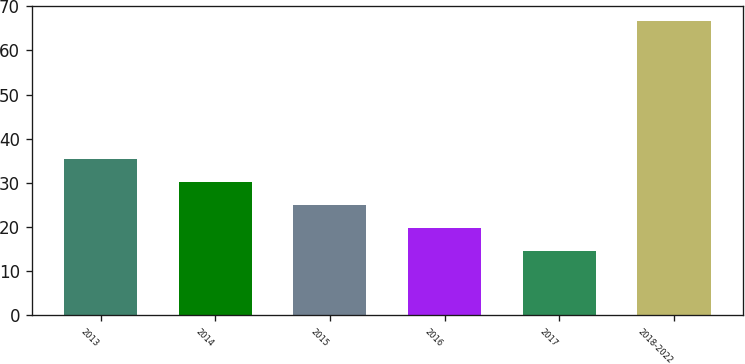Convert chart. <chart><loc_0><loc_0><loc_500><loc_500><bar_chart><fcel>2013<fcel>2014<fcel>2015<fcel>2016<fcel>2017<fcel>2018-2022<nl><fcel>35.44<fcel>30.23<fcel>25.02<fcel>19.81<fcel>14.6<fcel>66.7<nl></chart> 